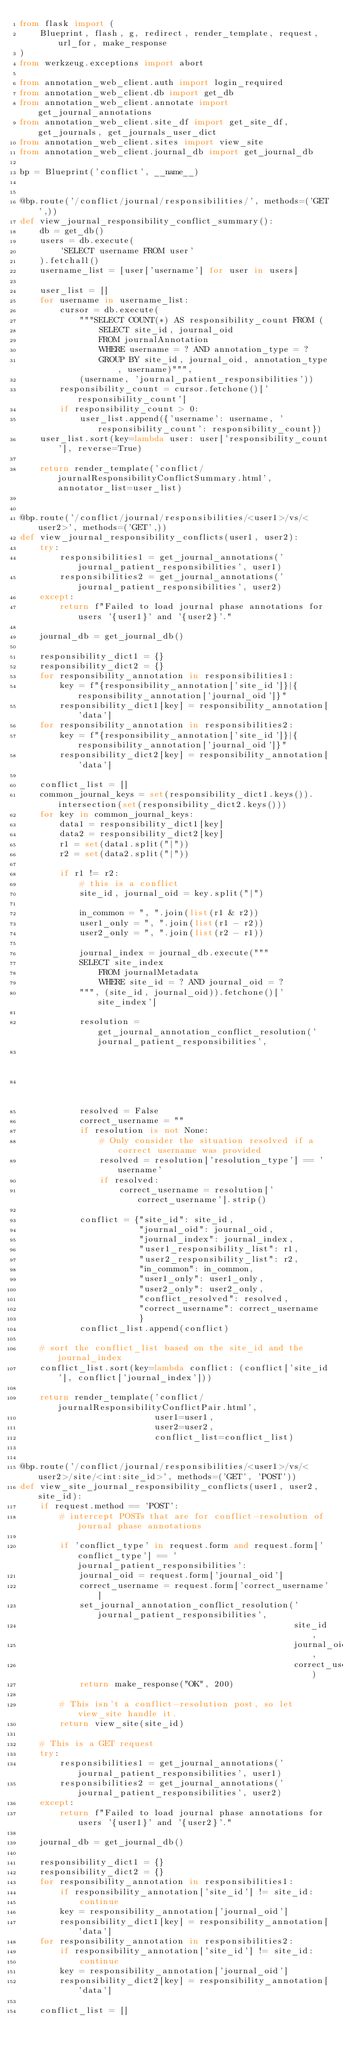<code> <loc_0><loc_0><loc_500><loc_500><_Python_>from flask import (
    Blueprint, flash, g, redirect, render_template, request, url_for, make_response
)
from werkzeug.exceptions import abort

from annotation_web_client.auth import login_required
from annotation_web_client.db import get_db
from annotation_web_client.annotate import get_journal_annotations
from annotation_web_client.site_df import get_site_df, get_journals, get_journals_user_dict
from annotation_web_client.sites import view_site
from annotation_web_client.journal_db import get_journal_db

bp = Blueprint('conflict', __name__)


@bp.route('/conflict/journal/responsibilities/', methods=('GET',))
def view_journal_responsibility_conflict_summary():
    db = get_db()
    users = db.execute(
        'SELECT username FROM user'
    ).fetchall()
    username_list = [user['username'] for user in users]

    user_list = []
    for username in username_list:
        cursor = db.execute(
            """SELECT COUNT(*) AS responsibility_count FROM (
                SELECT site_id, journal_oid 
                FROM journalAnnotation 
                WHERE username = ? AND annotation_type = ?
                GROUP BY site_id, journal_oid, annotation_type, username)""",
            (username, 'journal_patient_responsibilities'))
        responsibility_count = cursor.fetchone()['responsibility_count']
        if responsibility_count > 0:
            user_list.append({'username': username, 'responsibility_count': responsibility_count})
    user_list.sort(key=lambda user: user['responsibility_count'], reverse=True)

    return render_template('conflict/journalResponsibilityConflictSummary.html', annotator_list=user_list)


@bp.route('/conflict/journal/responsibilities/<user1>/vs/<user2>', methods=('GET',))
def view_journal_responsibility_conflicts(user1, user2):
    try:
        responsibilities1 = get_journal_annotations('journal_patient_responsibilities', user1)
        responsibilities2 = get_journal_annotations('journal_patient_responsibilities', user2)
    except:
        return f"Failed to load journal phase annotations for users '{user1}' and '{user2}'."

    journal_db = get_journal_db()

    responsibility_dict1 = {}
    responsibility_dict2 = {}
    for responsibility_annotation in responsibilities1:
        key = f"{responsibility_annotation['site_id']}|{responsibility_annotation['journal_oid']}"
        responsibility_dict1[key] = responsibility_annotation['data']
    for responsibility_annotation in responsibilities2:
        key = f"{responsibility_annotation['site_id']}|{responsibility_annotation['journal_oid']}"
        responsibility_dict2[key] = responsibility_annotation['data']

    conflict_list = []
    common_journal_keys = set(responsibility_dict1.keys()).intersection(set(responsibility_dict2.keys()))
    for key in common_journal_keys:
        data1 = responsibility_dict1[key]
        data2 = responsibility_dict2[key]
        r1 = set(data1.split("|"))
        r2 = set(data2.split("|"))

        if r1 != r2:
            # this is a conflict
            site_id, journal_oid = key.split("|")

            in_common = ", ".join(list(r1 & r2))
            user1_only = ", ".join(list(r1 - r2))
            user2_only = ", ".join(list(r2 - r1))

            journal_index = journal_db.execute("""
            SELECT site_index 
                FROM journalMetadata 
                WHERE site_id = ? AND journal_oid = ?
            """, (site_id, journal_oid)).fetchone()['site_index']

            resolution = get_journal_annotation_conflict_resolution('journal_patient_responsibilities',
                                                                    site_id,
                                                                    journal_oid)
            resolved = False
            correct_username = ""
            if resolution is not None:
                # Only consider the situation resolved if a correct username was provided
                resolved = resolution['resolution_type'] == 'username'
                if resolved:
                    correct_username = resolution['correct_username'].strip()

            conflict = {"site_id": site_id,
                        "journal_oid": journal_oid,
                        "journal_index": journal_index,
                        "user1_responsibility_list": r1,
                        "user2_responsibility_list": r2,
                        "in_common": in_common,
                        "user1_only": user1_only,
                        "user2_only": user2_only,
                        "conflict_resolved": resolved,
                        "correct_username": correct_username
                        }
            conflict_list.append(conflict)

    # sort the conflict_list based on the site_id and the journal_index
    conflict_list.sort(key=lambda conflict: (conflict['site_id'], conflict['journal_index']))

    return render_template('conflict/journalResponsibilityConflictPair.html',
                           user1=user1,
                           user2=user2,
                           conflict_list=conflict_list)


@bp.route('/conflict/journal/responsibilities/<user1>/vs/<user2>/site/<int:site_id>', methods=('GET', 'POST'))
def view_site_journal_responsibility_conflicts(user1, user2, site_id):
    if request.method == 'POST':
        # intercept POSTs that are for conflict-resolution of journal phase annotations

        if 'conflict_type' in request.form and request.form['conflict_type'] == 'journal_patient_responsibilities':
            journal_oid = request.form['journal_oid']
            correct_username = request.form['correct_username']
            set_journal_annotation_conflict_resolution('journal_patient_responsibilities',
                                                       site_id,
                                                       journal_oid,
                                                       correct_username)
            return make_response("OK", 200)

        # This isn't a conflict-resolution post, so let view_site handle it.
        return view_site(site_id)

    # This is a GET request
    try:
        responsibilities1 = get_journal_annotations('journal_patient_responsibilities', user1)
        responsibilities2 = get_journal_annotations('journal_patient_responsibilities', user2)
    except:
        return f"Failed to load journal phase annotations for users '{user1}' and '{user2}'."

    journal_db = get_journal_db()

    responsibility_dict1 = {}
    responsibility_dict2 = {}
    for responsibility_annotation in responsibilities1:
        if responsibility_annotation['site_id'] != site_id:
            continue
        key = responsibility_annotation['journal_oid']
        responsibility_dict1[key] = responsibility_annotation['data']
    for responsibility_annotation in responsibilities2:
        if responsibility_annotation['site_id'] != site_id:
            continue
        key = responsibility_annotation['journal_oid']
        responsibility_dict2[key] = responsibility_annotation['data']

    conflict_list = []</code> 